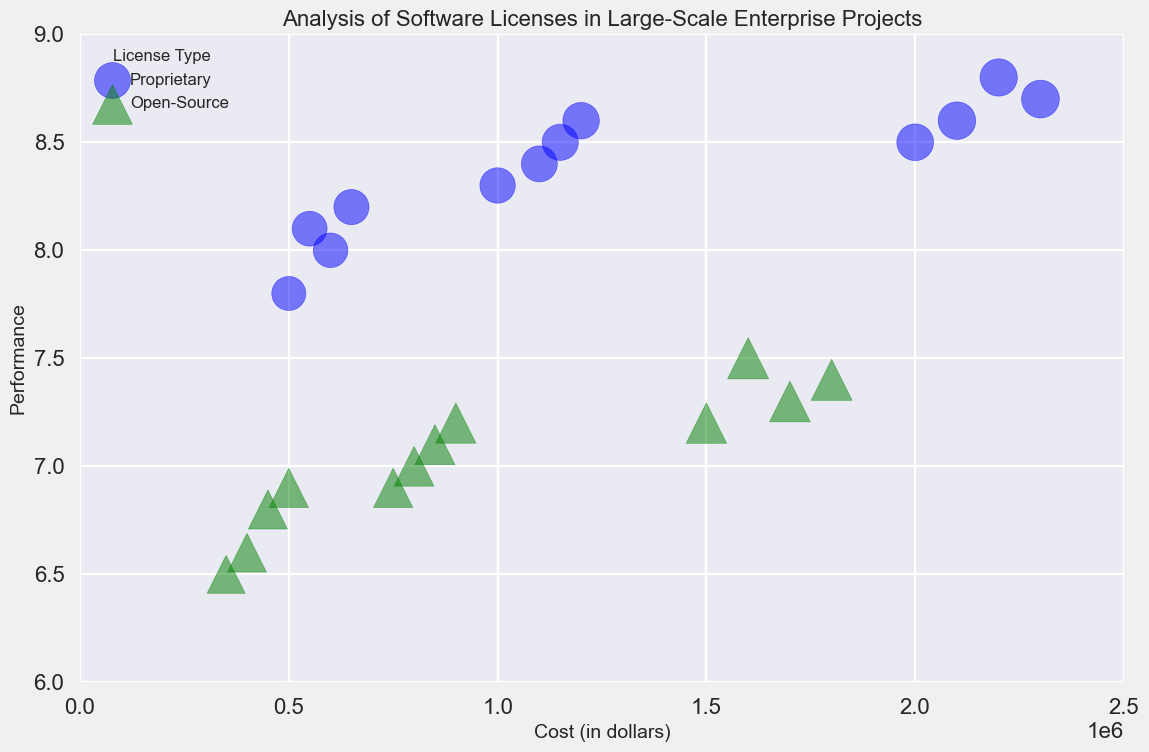What are the highest and lowest performance scores for proprietary software? By examining the figure, identify the data points with the highest and lowest y-values among the blue circles representing proprietary software. The highest score is 8.8, and the lowest is 7.8.
Answer: Highest: 8.8, Lowest: 7.8 Which software type generally has a higher performance score, proprietary or open-source? Observe the locations of the blue circles (proprietary) and green triangles (open-source) along the y-axis representing performance. Proprietary software generally has higher performance scores as its y-values are usually higher.
Answer: Proprietary What is the average cost of large-scale projects for open-source software? Identify the green triangles corresponding to the large projects and sum their x-values (1500000, 1600000, 1700000, 1800000). Divide by the number of data points, which is 4. The average cost is (1500000 + 1600000 + 1700000 + 1800000) / 4 = 1650000.
Answer: 1650000 For medium-sized projects, which license type has a wider range of performance scores? Compare the range of performance y-values for the medium-sized blue circles (proprietary, 8.3 to 8.6) and green triangles (open-source, 6.9 to 7.2). Proprietary has a wider range (8.6 - 8.3 = 0.3) than open-source (7.2 - 6.9 = 0.3). The ranges are equal.
Answer: The ranges are equal Which license type shows a more consistent popularity for small projects? Observe the sizes (indicative of popularity) of the blue circles (proprietary) and green triangles (open-source) for small projects. The sizes of the green triangles appear more uniform, indicating more consistent popularity among small open-source projects.
Answer: Open-Source Are there any large-scale open-source projects that outperform proprietary ones in terms of performance? Compare the y-values of green triangles (open-source, maximum performance of 7.5) for large projects with the y-values of blue circles (proprietary, minimum performance of 8.5) for large projects. No open-source large projects outperform proprietary ones in performance.
Answer: No What is the relationship between cost and performance for proprietary and open-source projects? Assess the general trend of blue circles and green triangles in the scatter plot. Proprietary projects show a positive correlation between cost and performance, whereas open-source projects depict a weaker positive correlation.
Answer: Proprietary: positive correlation; Open-Source: weak positive correlation Which license type is more popular overall in large-scale projects, and how can you tell? Compare the sizes of the green triangles (open-source) and blue circles (proprietary) for large projects. The green triangles are larger, indicating higher popularity values.
Answer: Open-Source Between medium-sized proprietary and open-source projects, which has the higher average popularity? Sum the popularity values of medium-sized proprietary projects (65, 67, 68, 69), which results in 269, and divide by 4 to get the average of 67.25. Sum the popularity values of medium-sized open-source projects (80, 82, 83, 84), which results in 329, and divide by 4 to get the average of 82.25.
Answer: Open-Source: 82.25 